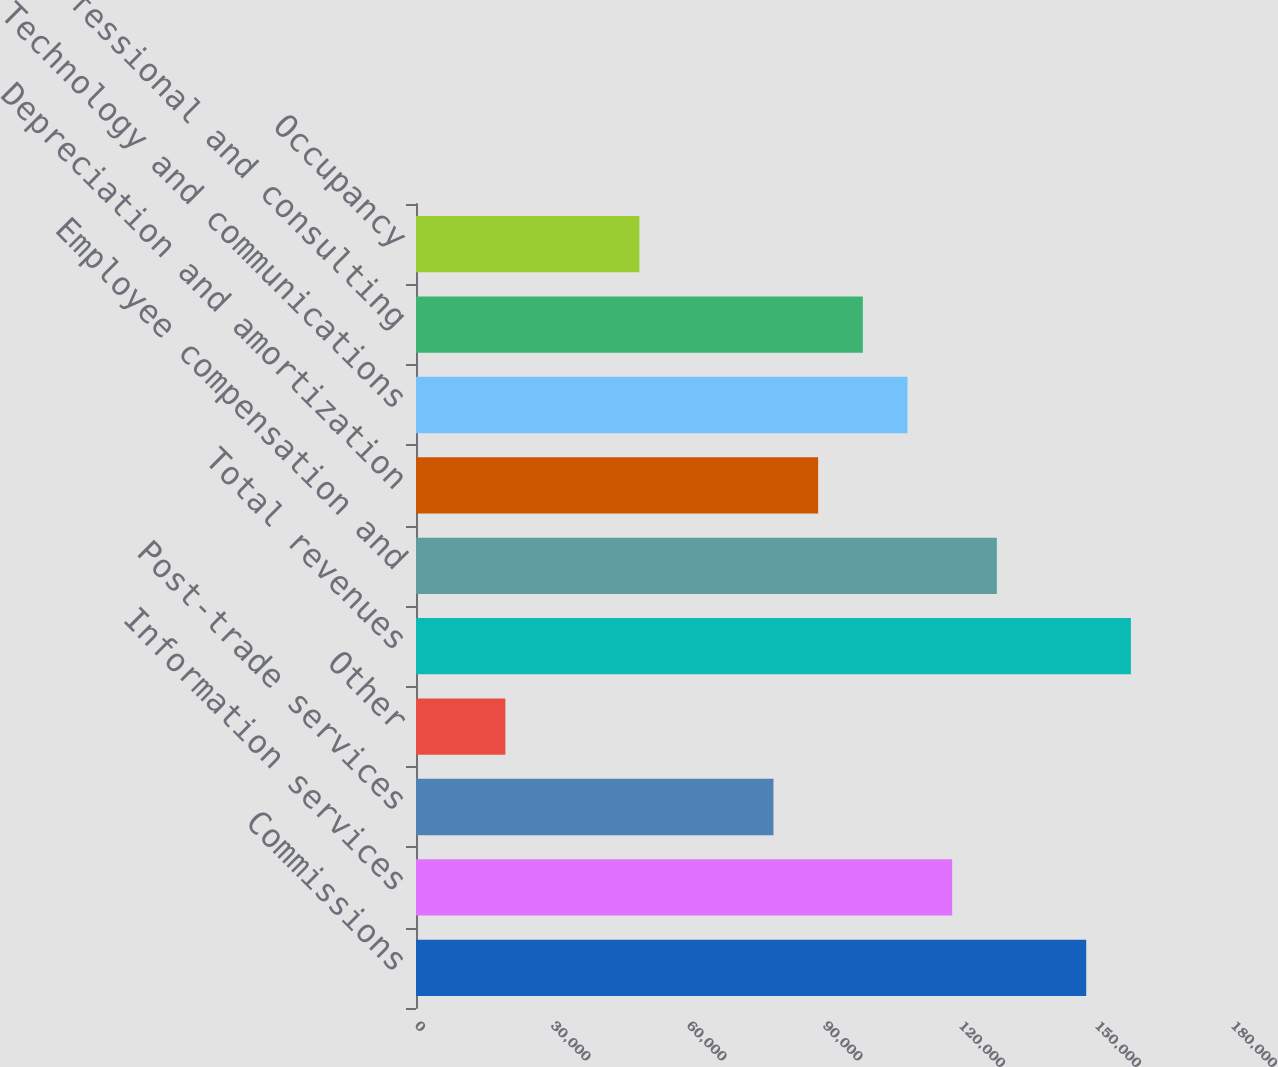Convert chart. <chart><loc_0><loc_0><loc_500><loc_500><bar_chart><fcel>Commissions<fcel>Information services<fcel>Post-trade services<fcel>Other<fcel>Total revenues<fcel>Employee compensation and<fcel>Depreciation and amortization<fcel>Technology and communications<fcel>Professional and consulting<fcel>Occupancy<nl><fcel>147840<fcel>118272<fcel>78848.2<fcel>19712.7<fcel>157695<fcel>128128<fcel>88704.1<fcel>108416<fcel>98560<fcel>49280.4<nl></chart> 